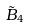<formula> <loc_0><loc_0><loc_500><loc_500>\tilde { B } _ { 4 }</formula> 